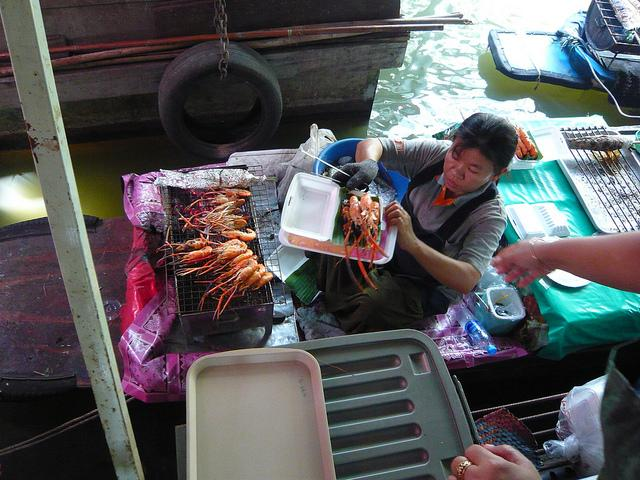What is this person's profession?

Choices:
A) singer
B) dancer
C) lawyer
D) fisherman fisherman 